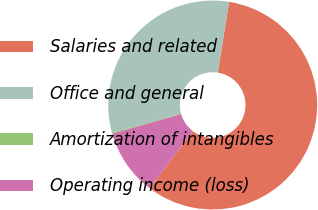Convert chart to OTSL. <chart><loc_0><loc_0><loc_500><loc_500><pie_chart><fcel>Salaries and related<fcel>Office and general<fcel>Amortization of intangibles<fcel>Operating income (loss)<nl><fcel>57.83%<fcel>31.75%<fcel>0.18%<fcel>10.24%<nl></chart> 